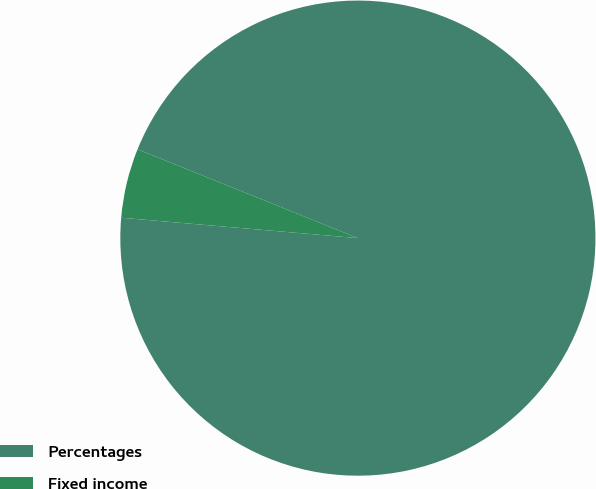<chart> <loc_0><loc_0><loc_500><loc_500><pie_chart><fcel>Percentages<fcel>Fixed income<nl><fcel>95.27%<fcel>4.73%<nl></chart> 